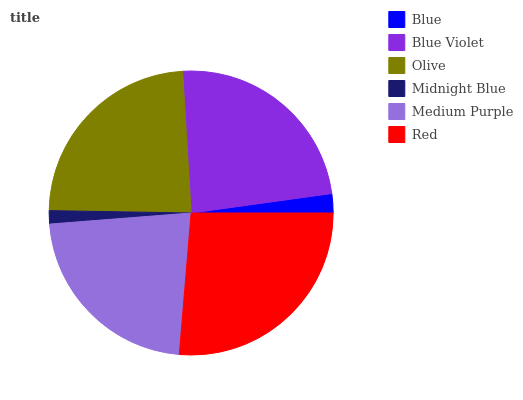Is Midnight Blue the minimum?
Answer yes or no. Yes. Is Red the maximum?
Answer yes or no. Yes. Is Blue Violet the minimum?
Answer yes or no. No. Is Blue Violet the maximum?
Answer yes or no. No. Is Blue Violet greater than Blue?
Answer yes or no. Yes. Is Blue less than Blue Violet?
Answer yes or no. Yes. Is Blue greater than Blue Violet?
Answer yes or no. No. Is Blue Violet less than Blue?
Answer yes or no. No. Is Olive the high median?
Answer yes or no. Yes. Is Medium Purple the low median?
Answer yes or no. Yes. Is Medium Purple the high median?
Answer yes or no. No. Is Red the low median?
Answer yes or no. No. 